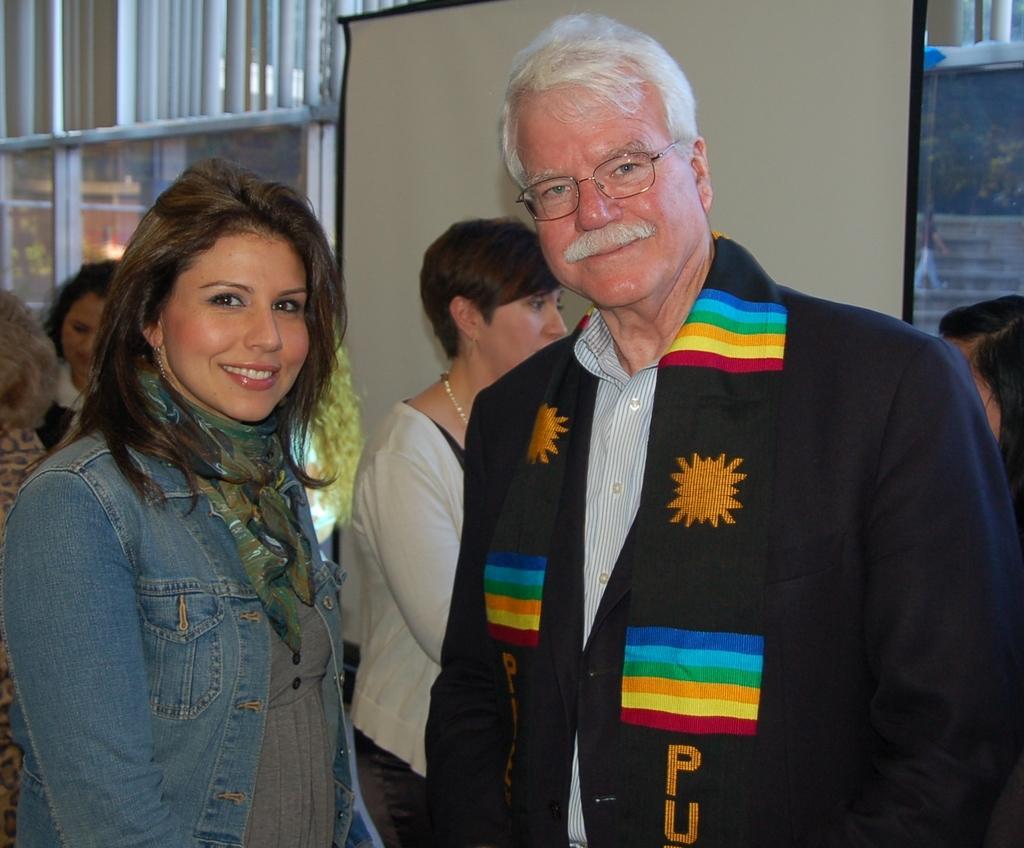Please provide a concise description of this image. In this image I can see few people with different color dresses. In the background I can see the board and the glass. Through the glass I can see one person, stairs and the trees. 